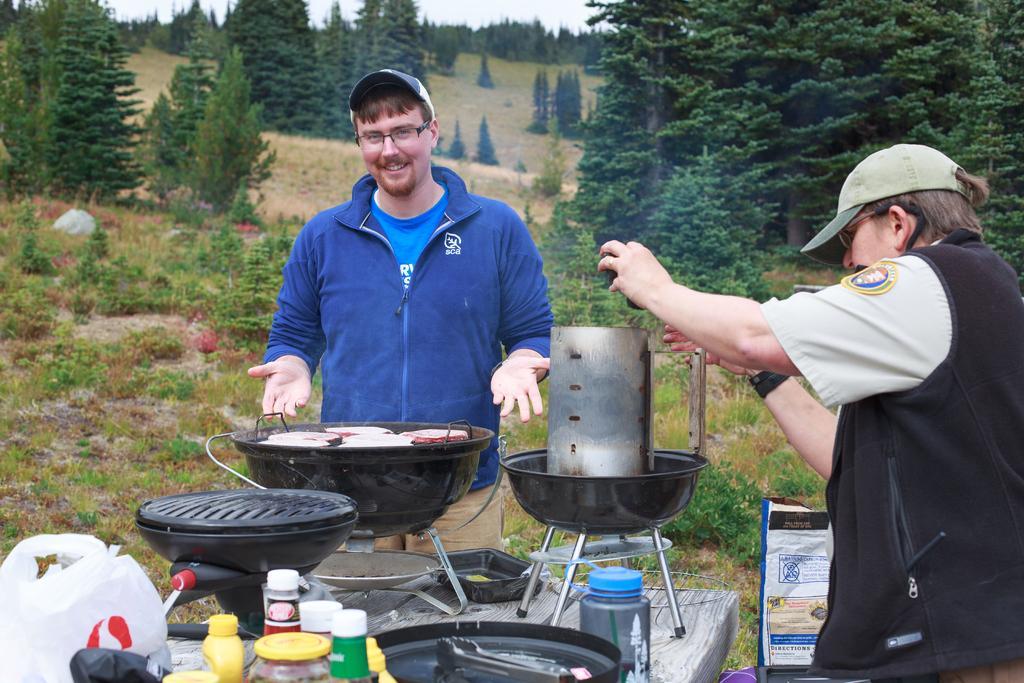Can you describe this image briefly? In the foreground of this image, on the table,there are few grill stoves, bottle, few containers, covers and atong are placed. Around the table, there are two men standing and cooking. On the right bottom, it seems like a cover. In the background, there are trees, land and the sky. 